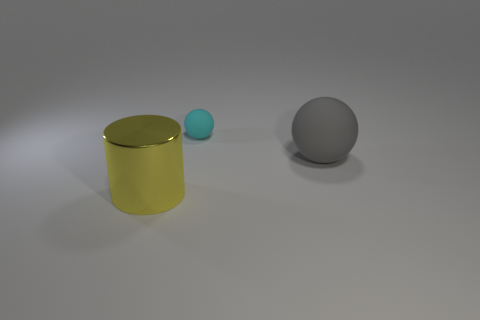Is the number of large gray spheres on the right side of the cylinder greater than the number of small green metallic cubes?
Provide a short and direct response. Yes. The cyan thing that is made of the same material as the gray ball is what size?
Your response must be concise. Small. How many things are big brown shiny blocks or rubber balls on the right side of the small cyan ball?
Ensure brevity in your answer.  1. Is the number of yellow cylinders greater than the number of small yellow cylinders?
Make the answer very short. Yes. Is there a cyan sphere made of the same material as the gray ball?
Keep it short and to the point. Yes. What shape is the thing that is in front of the small thing and on the left side of the gray sphere?
Keep it short and to the point. Cylinder. How many other objects are there of the same shape as the gray matte thing?
Your answer should be compact. 1. The cyan ball has what size?
Offer a very short reply. Small. What number of objects are large brown things or cyan things?
Provide a succinct answer. 1. What is the size of the thing in front of the gray rubber sphere?
Offer a very short reply. Large. 